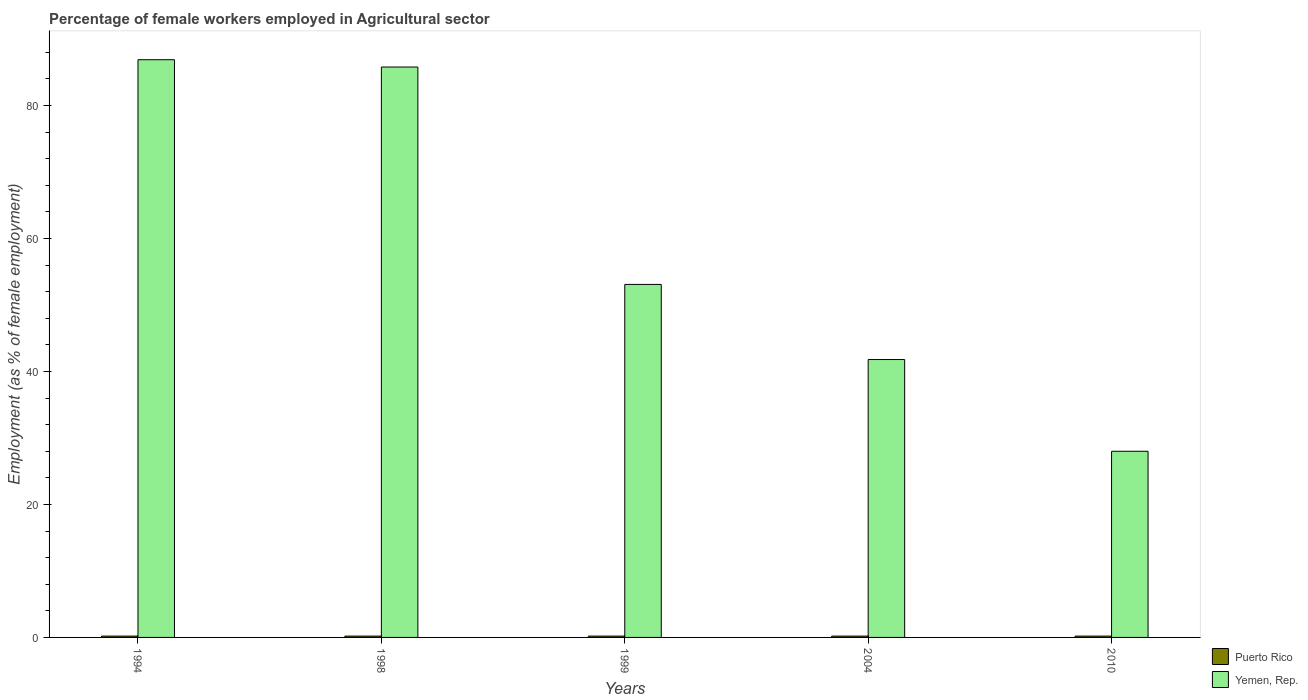How many groups of bars are there?
Make the answer very short. 5. Are the number of bars per tick equal to the number of legend labels?
Offer a terse response. Yes. How many bars are there on the 1st tick from the right?
Your response must be concise. 2. What is the percentage of females employed in Agricultural sector in Puerto Rico in 1998?
Your response must be concise. 0.2. Across all years, what is the maximum percentage of females employed in Agricultural sector in Puerto Rico?
Ensure brevity in your answer.  0.2. Across all years, what is the minimum percentage of females employed in Agricultural sector in Yemen, Rep.?
Keep it short and to the point. 28. What is the total percentage of females employed in Agricultural sector in Yemen, Rep. in the graph?
Ensure brevity in your answer.  295.6. What is the difference between the percentage of females employed in Agricultural sector in Yemen, Rep. in 1994 and that in 1999?
Your answer should be very brief. 33.8. What is the difference between the percentage of females employed in Agricultural sector in Yemen, Rep. in 1998 and the percentage of females employed in Agricultural sector in Puerto Rico in 1999?
Your answer should be very brief. 85.6. What is the average percentage of females employed in Agricultural sector in Puerto Rico per year?
Your answer should be compact. 0.2. In the year 2004, what is the difference between the percentage of females employed in Agricultural sector in Yemen, Rep. and percentage of females employed in Agricultural sector in Puerto Rico?
Provide a short and direct response. 41.6. What is the ratio of the percentage of females employed in Agricultural sector in Yemen, Rep. in 1998 to that in 2010?
Ensure brevity in your answer.  3.06. What is the difference between the highest and the second highest percentage of females employed in Agricultural sector in Yemen, Rep.?
Provide a short and direct response. 1.1. What is the difference between the highest and the lowest percentage of females employed in Agricultural sector in Yemen, Rep.?
Provide a succinct answer. 58.9. What does the 1st bar from the left in 1994 represents?
Your answer should be very brief. Puerto Rico. What does the 2nd bar from the right in 1999 represents?
Give a very brief answer. Puerto Rico. Are all the bars in the graph horizontal?
Your answer should be very brief. No. How many years are there in the graph?
Provide a succinct answer. 5. Are the values on the major ticks of Y-axis written in scientific E-notation?
Give a very brief answer. No. Does the graph contain any zero values?
Provide a short and direct response. No. Does the graph contain grids?
Provide a short and direct response. No. Where does the legend appear in the graph?
Keep it short and to the point. Bottom right. What is the title of the graph?
Provide a short and direct response. Percentage of female workers employed in Agricultural sector. What is the label or title of the Y-axis?
Keep it short and to the point. Employment (as % of female employment). What is the Employment (as % of female employment) in Puerto Rico in 1994?
Keep it short and to the point. 0.2. What is the Employment (as % of female employment) of Yemen, Rep. in 1994?
Provide a short and direct response. 86.9. What is the Employment (as % of female employment) in Puerto Rico in 1998?
Ensure brevity in your answer.  0.2. What is the Employment (as % of female employment) in Yemen, Rep. in 1998?
Your answer should be very brief. 85.8. What is the Employment (as % of female employment) in Puerto Rico in 1999?
Provide a succinct answer. 0.2. What is the Employment (as % of female employment) in Yemen, Rep. in 1999?
Keep it short and to the point. 53.1. What is the Employment (as % of female employment) of Puerto Rico in 2004?
Ensure brevity in your answer.  0.2. What is the Employment (as % of female employment) of Yemen, Rep. in 2004?
Provide a short and direct response. 41.8. What is the Employment (as % of female employment) of Puerto Rico in 2010?
Make the answer very short. 0.2. What is the Employment (as % of female employment) in Yemen, Rep. in 2010?
Keep it short and to the point. 28. Across all years, what is the maximum Employment (as % of female employment) of Puerto Rico?
Offer a very short reply. 0.2. Across all years, what is the maximum Employment (as % of female employment) of Yemen, Rep.?
Provide a succinct answer. 86.9. Across all years, what is the minimum Employment (as % of female employment) in Puerto Rico?
Provide a succinct answer. 0.2. Across all years, what is the minimum Employment (as % of female employment) of Yemen, Rep.?
Your answer should be compact. 28. What is the total Employment (as % of female employment) in Yemen, Rep. in the graph?
Provide a succinct answer. 295.6. What is the difference between the Employment (as % of female employment) of Puerto Rico in 1994 and that in 1998?
Give a very brief answer. 0. What is the difference between the Employment (as % of female employment) of Yemen, Rep. in 1994 and that in 1999?
Give a very brief answer. 33.8. What is the difference between the Employment (as % of female employment) of Yemen, Rep. in 1994 and that in 2004?
Offer a terse response. 45.1. What is the difference between the Employment (as % of female employment) in Yemen, Rep. in 1994 and that in 2010?
Your answer should be compact. 58.9. What is the difference between the Employment (as % of female employment) in Yemen, Rep. in 1998 and that in 1999?
Make the answer very short. 32.7. What is the difference between the Employment (as % of female employment) of Puerto Rico in 1998 and that in 2004?
Ensure brevity in your answer.  0. What is the difference between the Employment (as % of female employment) in Yemen, Rep. in 1998 and that in 2004?
Offer a terse response. 44. What is the difference between the Employment (as % of female employment) in Yemen, Rep. in 1998 and that in 2010?
Your response must be concise. 57.8. What is the difference between the Employment (as % of female employment) in Yemen, Rep. in 1999 and that in 2010?
Provide a short and direct response. 25.1. What is the difference between the Employment (as % of female employment) in Puerto Rico in 1994 and the Employment (as % of female employment) in Yemen, Rep. in 1998?
Your answer should be very brief. -85.6. What is the difference between the Employment (as % of female employment) of Puerto Rico in 1994 and the Employment (as % of female employment) of Yemen, Rep. in 1999?
Provide a succinct answer. -52.9. What is the difference between the Employment (as % of female employment) in Puerto Rico in 1994 and the Employment (as % of female employment) in Yemen, Rep. in 2004?
Provide a succinct answer. -41.6. What is the difference between the Employment (as % of female employment) of Puerto Rico in 1994 and the Employment (as % of female employment) of Yemen, Rep. in 2010?
Your answer should be compact. -27.8. What is the difference between the Employment (as % of female employment) of Puerto Rico in 1998 and the Employment (as % of female employment) of Yemen, Rep. in 1999?
Your answer should be very brief. -52.9. What is the difference between the Employment (as % of female employment) of Puerto Rico in 1998 and the Employment (as % of female employment) of Yemen, Rep. in 2004?
Your response must be concise. -41.6. What is the difference between the Employment (as % of female employment) in Puerto Rico in 1998 and the Employment (as % of female employment) in Yemen, Rep. in 2010?
Your answer should be very brief. -27.8. What is the difference between the Employment (as % of female employment) in Puerto Rico in 1999 and the Employment (as % of female employment) in Yemen, Rep. in 2004?
Your response must be concise. -41.6. What is the difference between the Employment (as % of female employment) of Puerto Rico in 1999 and the Employment (as % of female employment) of Yemen, Rep. in 2010?
Ensure brevity in your answer.  -27.8. What is the difference between the Employment (as % of female employment) in Puerto Rico in 2004 and the Employment (as % of female employment) in Yemen, Rep. in 2010?
Your answer should be very brief. -27.8. What is the average Employment (as % of female employment) in Yemen, Rep. per year?
Offer a terse response. 59.12. In the year 1994, what is the difference between the Employment (as % of female employment) of Puerto Rico and Employment (as % of female employment) of Yemen, Rep.?
Provide a succinct answer. -86.7. In the year 1998, what is the difference between the Employment (as % of female employment) of Puerto Rico and Employment (as % of female employment) of Yemen, Rep.?
Provide a short and direct response. -85.6. In the year 1999, what is the difference between the Employment (as % of female employment) of Puerto Rico and Employment (as % of female employment) of Yemen, Rep.?
Your response must be concise. -52.9. In the year 2004, what is the difference between the Employment (as % of female employment) in Puerto Rico and Employment (as % of female employment) in Yemen, Rep.?
Keep it short and to the point. -41.6. In the year 2010, what is the difference between the Employment (as % of female employment) of Puerto Rico and Employment (as % of female employment) of Yemen, Rep.?
Give a very brief answer. -27.8. What is the ratio of the Employment (as % of female employment) of Yemen, Rep. in 1994 to that in 1998?
Your answer should be very brief. 1.01. What is the ratio of the Employment (as % of female employment) of Puerto Rico in 1994 to that in 1999?
Your answer should be compact. 1. What is the ratio of the Employment (as % of female employment) in Yemen, Rep. in 1994 to that in 1999?
Ensure brevity in your answer.  1.64. What is the ratio of the Employment (as % of female employment) in Puerto Rico in 1994 to that in 2004?
Provide a short and direct response. 1. What is the ratio of the Employment (as % of female employment) in Yemen, Rep. in 1994 to that in 2004?
Provide a short and direct response. 2.08. What is the ratio of the Employment (as % of female employment) of Yemen, Rep. in 1994 to that in 2010?
Provide a short and direct response. 3.1. What is the ratio of the Employment (as % of female employment) of Puerto Rico in 1998 to that in 1999?
Offer a very short reply. 1. What is the ratio of the Employment (as % of female employment) of Yemen, Rep. in 1998 to that in 1999?
Offer a very short reply. 1.62. What is the ratio of the Employment (as % of female employment) of Yemen, Rep. in 1998 to that in 2004?
Keep it short and to the point. 2.05. What is the ratio of the Employment (as % of female employment) of Puerto Rico in 1998 to that in 2010?
Ensure brevity in your answer.  1. What is the ratio of the Employment (as % of female employment) of Yemen, Rep. in 1998 to that in 2010?
Your answer should be compact. 3.06. What is the ratio of the Employment (as % of female employment) of Yemen, Rep. in 1999 to that in 2004?
Provide a short and direct response. 1.27. What is the ratio of the Employment (as % of female employment) in Yemen, Rep. in 1999 to that in 2010?
Keep it short and to the point. 1.9. What is the ratio of the Employment (as % of female employment) of Puerto Rico in 2004 to that in 2010?
Your answer should be compact. 1. What is the ratio of the Employment (as % of female employment) of Yemen, Rep. in 2004 to that in 2010?
Your answer should be very brief. 1.49. What is the difference between the highest and the lowest Employment (as % of female employment) in Puerto Rico?
Keep it short and to the point. 0. What is the difference between the highest and the lowest Employment (as % of female employment) in Yemen, Rep.?
Provide a short and direct response. 58.9. 